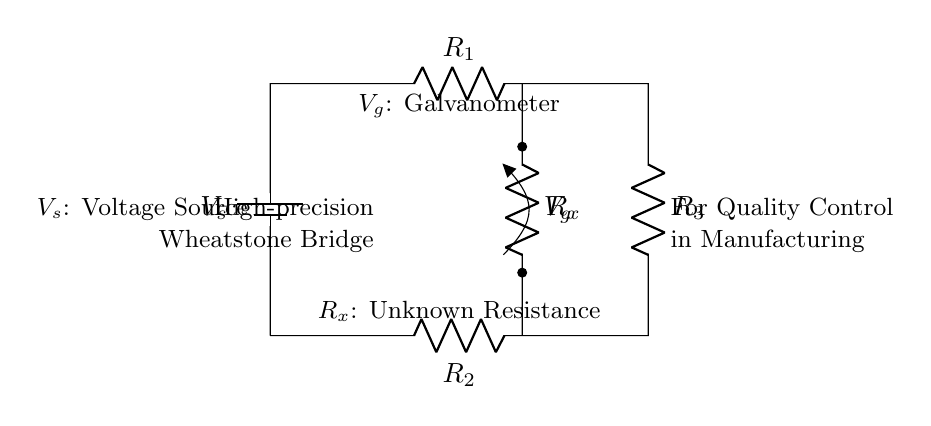What is the configuration of the bridge circuit? The circuit is configured as a Wheatstone bridge with four resistors arranged in a diamond shape and a galvanometer for measuring the balance.
Answer: Wheatstone bridge What is the purpose of resistor R_x in this circuit? R_x represents the unknown resistance that we want to measure using the bridge. It is placed in one of the arms of the circuit to determine its value based on the balance condition.
Answer: Unknown resistance How many resistors are present in the Wheatstone bridge? The Wheatstone bridge circuit consists of four resistors: R_1, R_2, R_3, and R_x.
Answer: Four What indicates a balanced Wheatstone bridge? A balanced bridge is indicated by zero voltage across the galvanometer (V_g) when no current flows through it, meaning the ratios of the resistances are equal.
Answer: Zero voltage across the galvanometer What does the galvanometer measure in this circuit? The galvanometer measures the potential difference between the two midpoints of the bridge, indicating whether the bridge is balanced or unbalanced.
Answer: Potential difference How can we adjust the resistance in a Wheatstone bridge? Adjustments can be made by varying the known resistances, R_1, R_2, or R_3, to achieve a balance where the galvanometer reads zero.
Answer: Varying known resistances 